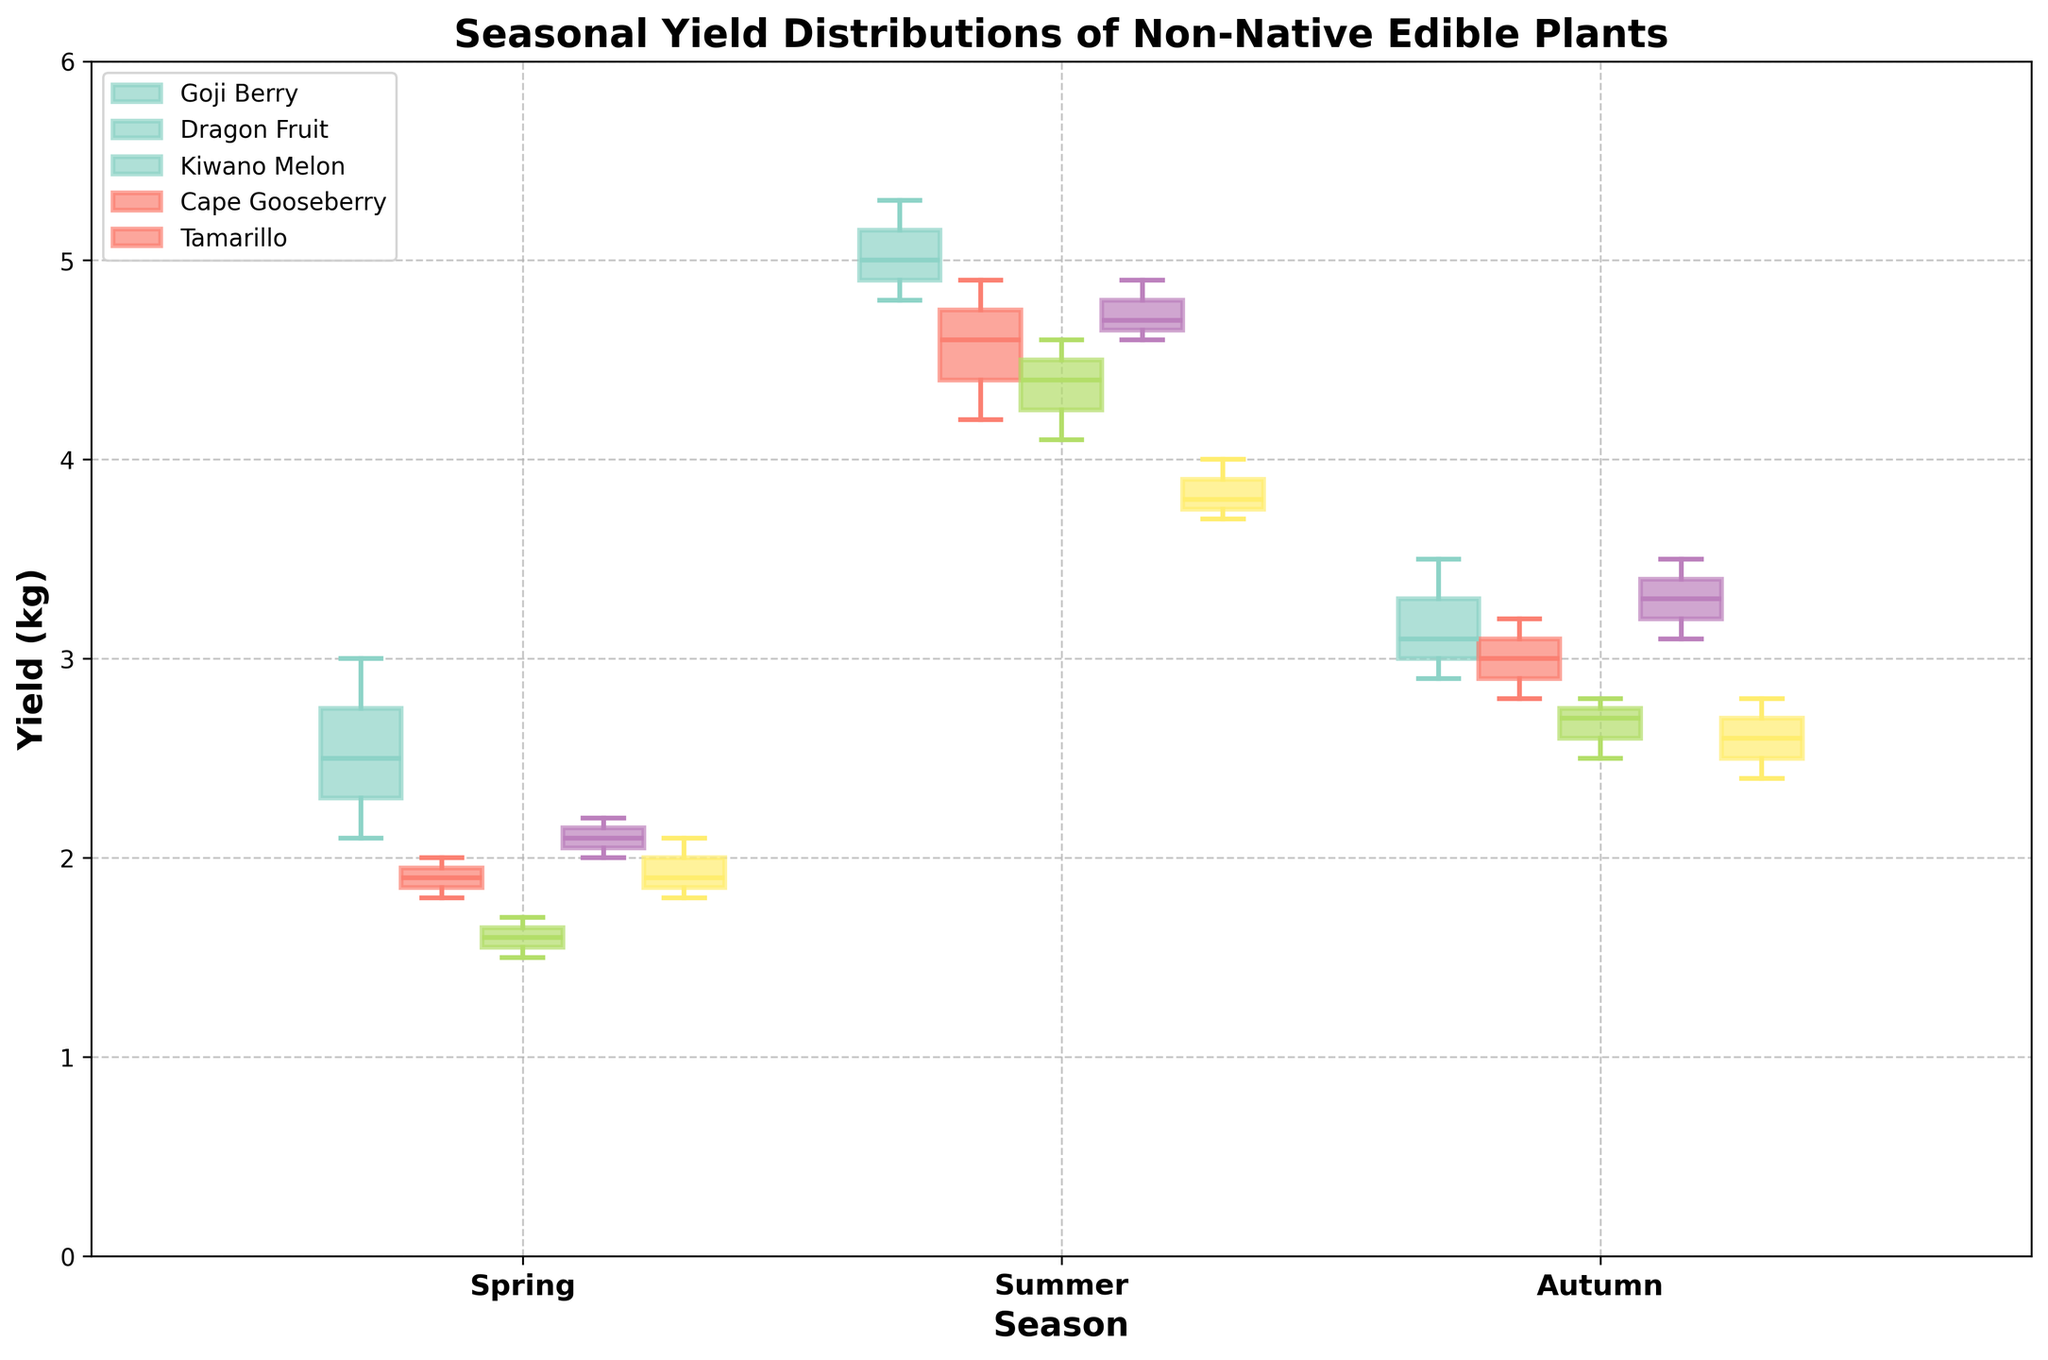What does the title of the figure indicate? The title of the figure is "Seasonal Yield Distributions of Non-Native Edible Plants in Home Gardens." It indicates that the graph shows the distribution of yields for various non-native edible plants over different seasons.
Answer: Seasonal Yield Distributions of Non-Native Edible Plants in Home Gardens Which plant shows the highest yield in summer? To find the plant with the highest yield in summer, look at the summer data for each plant and identify the highest value. For Goji Berry: near 5.3 kg, Dragon Fruit: near 4.9 kg, Kiwano Melon: near 4.6 kg, Cape Gooseberry: near 4.9 kg, and Tamarillo: near 4.0 kg. So, both Dragon Fruit and Cape Gooseberry have the highest yield in summer.
Answer: Dragon Fruit and Cape Gooseberry How does the spring yield of Dragon Fruit compare to the spring yield of Cape Gooseberry? Compare the spring box plots for Dragon Fruit and Cape Gooseberry. Dragon Fruit's yield in spring ranges from 1.8 to 2.0 kg, whereas Cape Gooseberry's yield ranges from 2.0 to 2.2 kg. Therefore, Cape Gooseberry generally has a higher yield in spring.
Answer: Cape Gooseberry has a higher yield What is the median yield of Kiwano Melon in autumn? To find the median yield, look at the line inside the box in the autumn box plot for Kiwano Melon. The median is approximately 2.7 kg.
Answer: 2.7 kg Which plant shows the lowest variability in yield during spring? The plant with the lowest variability in yield will have the smallest interquartile range in the spring box plot. Comparing the spring box plots, Cape Gooseberry has the smallest box, indicating the lowest variability.
Answer: Cape Gooseberry What is the range of yields for Tamarillo in summer? The range can be found by subtracting the minimum value from the maximum value in the summer box plot for Tamarillo. Maximum: 4.0 kg, Minimum: 3.7 kg. Range: 4.0 - 3.7 = 0.3 kg.
Answer: 0.3 kg Which season shows the highest median yield for Goji Berry? To find this, compare the medians for Goji Berry across all seasons. Spring: around 2.5 kg, Summer: around 5.0 kg, Autumn: around 3.1 kg. Thus, summer has the highest median yield for Goji Berry.
Answer: Summer Do any plants have similar yield distributions in autumn? Check the autumn box plots for plants with overlapping range boxes and similar medians. Dragon Fruit and Cape Gooseberry have very similar yield distributions in autumn, both centered around 3 kg.
Answer: Dragon Fruit and Cape Gooseberry What's the difference in median yields between Tamarillo and Goji Berry in autumn? Find the medians in autumn for both plants. Tamarillo: around 2.6 kg, Goji Berry: around 3.1 kg. Difference: 3.1 - 2.6 = 0.5 kg.
Answer: 0.5 kg 